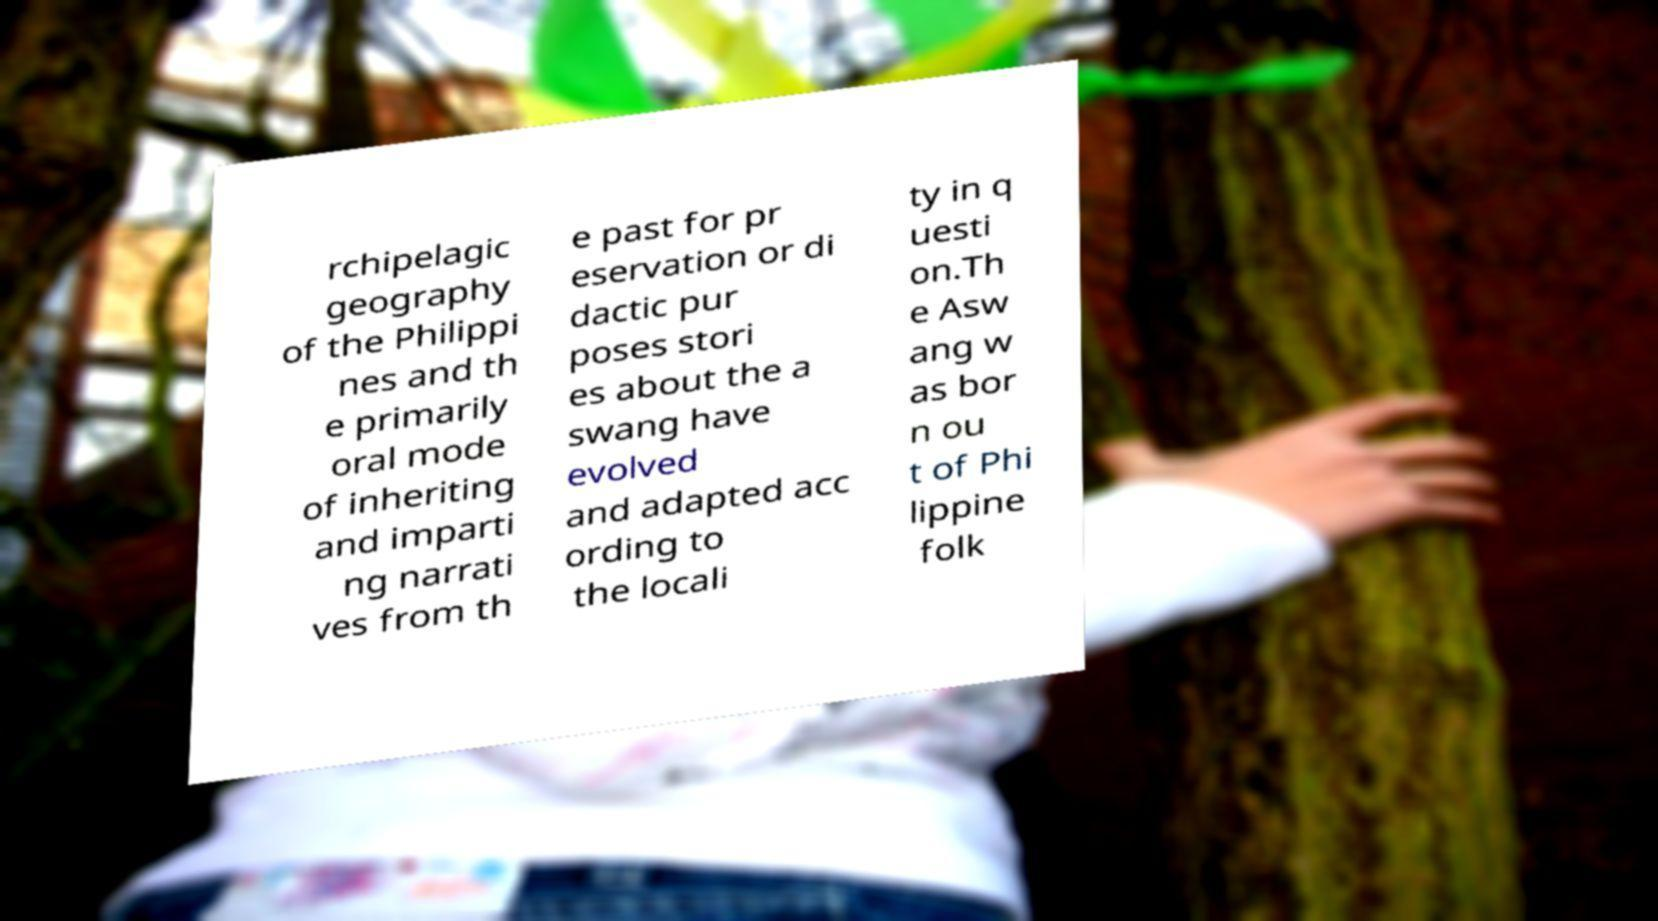Can you read and provide the text displayed in the image?This photo seems to have some interesting text. Can you extract and type it out for me? rchipelagic geography of the Philippi nes and th e primarily oral mode of inheriting and imparti ng narrati ves from th e past for pr eservation or di dactic pur poses stori es about the a swang have evolved and adapted acc ording to the locali ty in q uesti on.Th e Asw ang w as bor n ou t of Phi lippine folk 